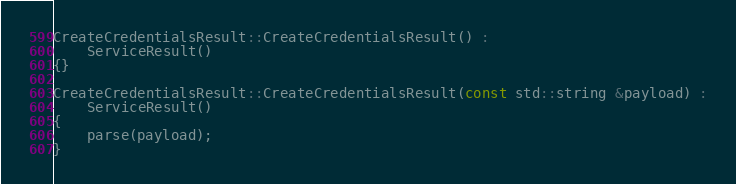Convert code to text. <code><loc_0><loc_0><loc_500><loc_500><_C++_>
CreateCredentialsResult::CreateCredentialsResult() :
	ServiceResult()
{}

CreateCredentialsResult::CreateCredentialsResult(const std::string &payload) :
	ServiceResult()
{
	parse(payload);
}
</code> 